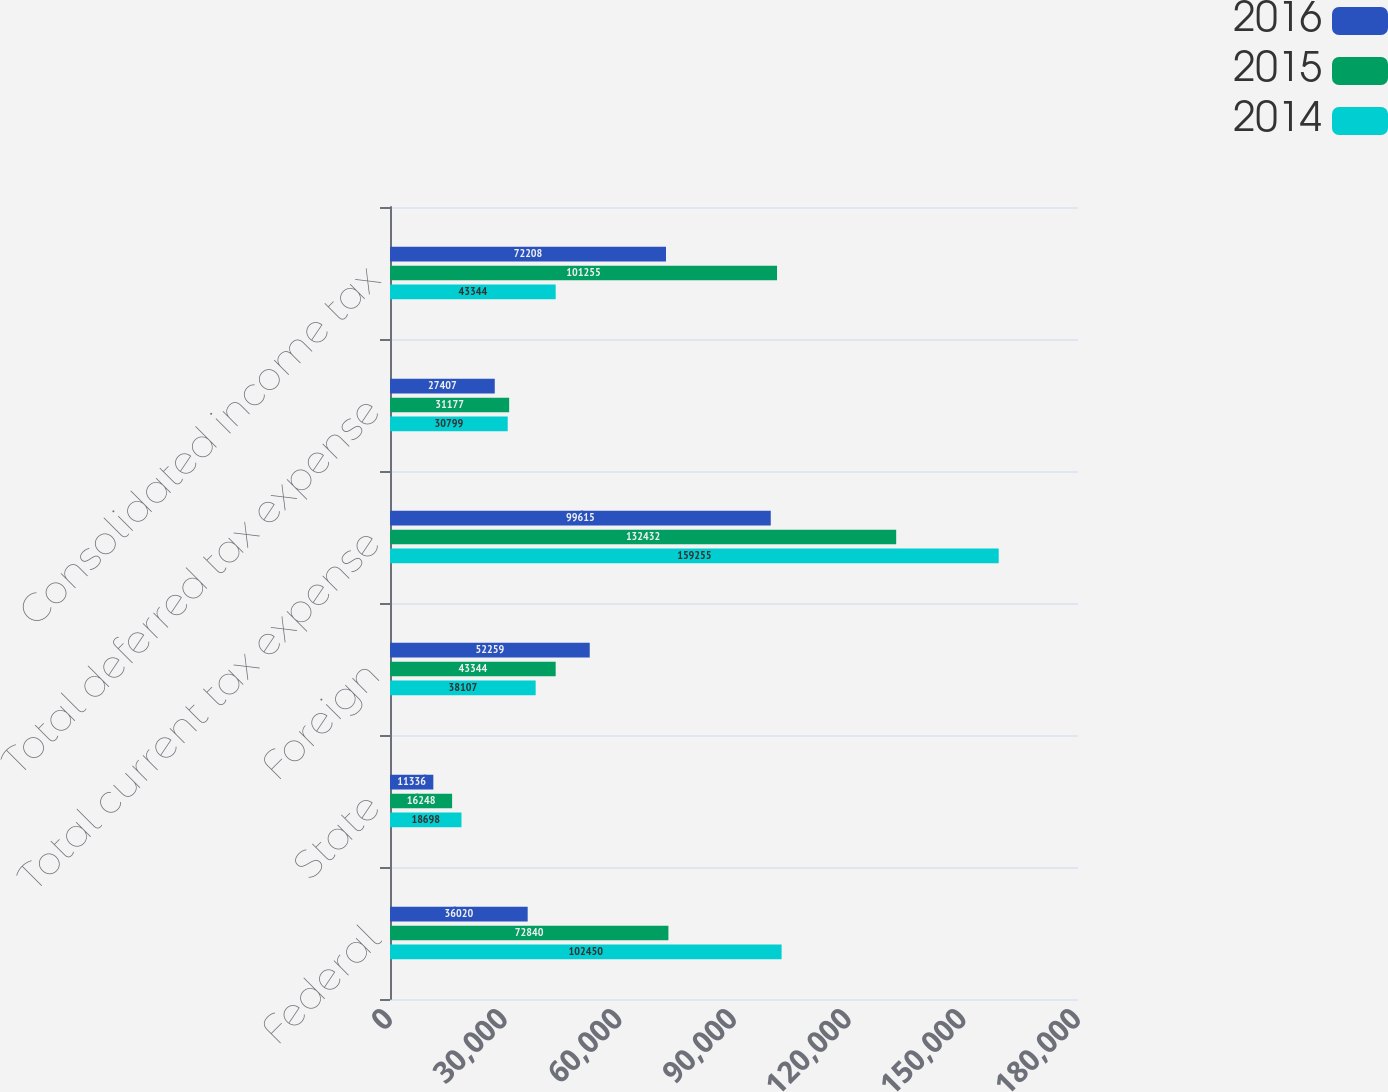Convert chart to OTSL. <chart><loc_0><loc_0><loc_500><loc_500><stacked_bar_chart><ecel><fcel>Federal<fcel>State<fcel>Foreign<fcel>Total current tax expense<fcel>Total deferred tax expense<fcel>Consolidated income tax<nl><fcel>2016<fcel>36020<fcel>11336<fcel>52259<fcel>99615<fcel>27407<fcel>72208<nl><fcel>2015<fcel>72840<fcel>16248<fcel>43344<fcel>132432<fcel>31177<fcel>101255<nl><fcel>2014<fcel>102450<fcel>18698<fcel>38107<fcel>159255<fcel>30799<fcel>43344<nl></chart> 